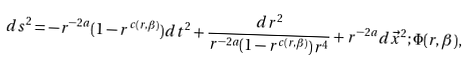<formula> <loc_0><loc_0><loc_500><loc_500>d s ^ { 2 } = - r ^ { - 2 a } ( 1 - r ^ { c ( r , \beta ) } ) d t ^ { 2 } + \frac { d r ^ { 2 } } { r ^ { - 2 a } ( 1 - r ^ { c ( r , \beta ) } ) r ^ { 4 } } + r ^ { - 2 a } d \vec { x } ^ { 2 } ; \Phi ( r , \beta ) ,</formula> 